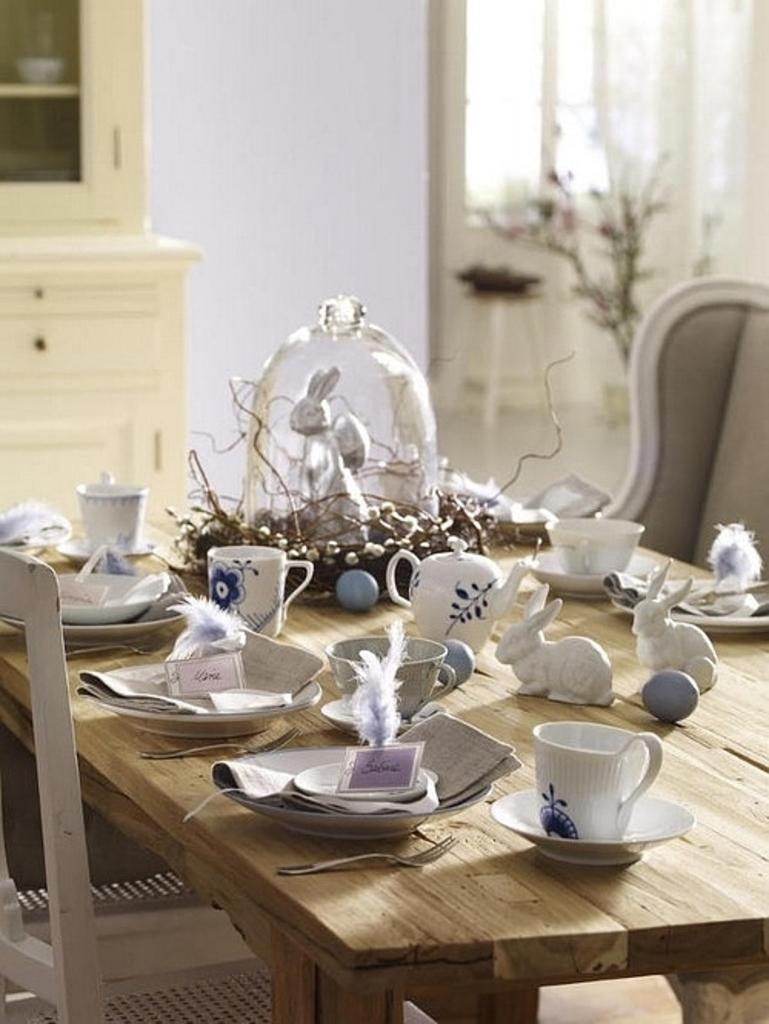What type of furniture is present in the image? There is a table and a chair in the image. What items can be seen on the table? There is a plate, a fork, a cup, and rabbit toys on the table. What is visible in the background of the image? There is a cupboard, a window, and a flower vase in the background of the image. What is the order of the planets in the image? There are no planets present in the image; it features a table, chair, and various items on the table. 